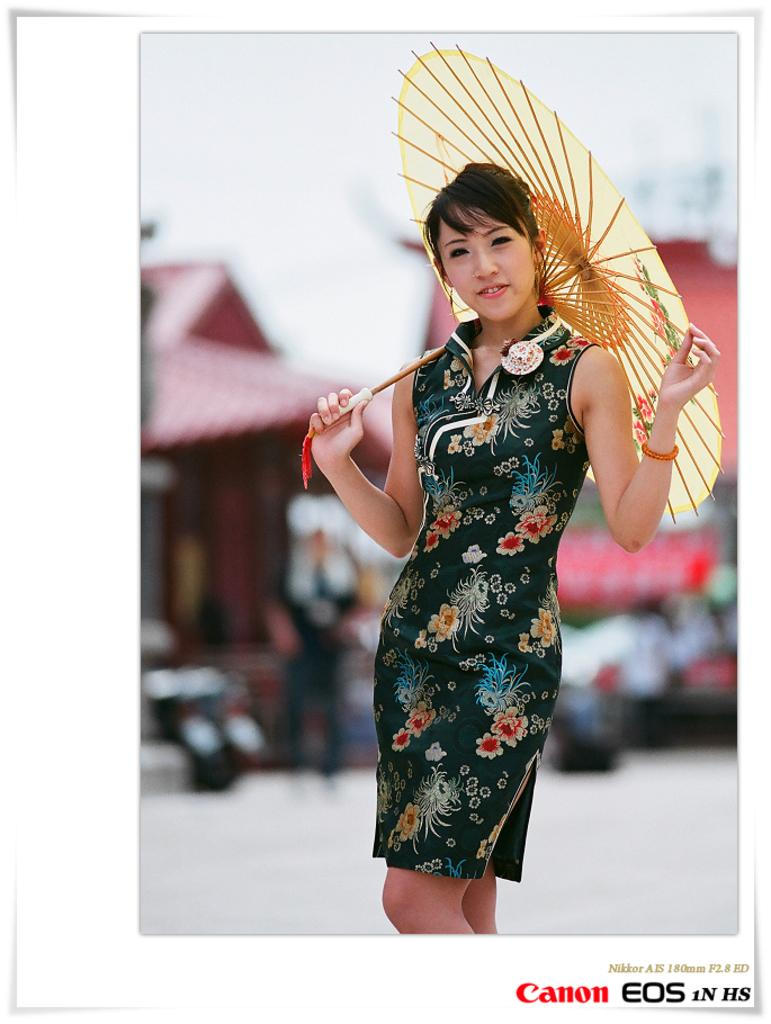Who is present in the image? There is a woman in the image. What is the woman holding in the image? The woman is holding an umbrella. Can you describe the background of the image? The background of the image is blurred. How many people are visible in the image? There is one person visible in the image, which is the woman. What type of structure can be seen in the image? There is a house in the image. What is written at the bottom of the image? There is text written at the bottom of the image. What year is depicted in the image? There is no specific year depicted in the image. Can you see any waves in the image? There are no waves present in the image. 